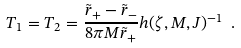Convert formula to latex. <formula><loc_0><loc_0><loc_500><loc_500>T _ { 1 } = T _ { 2 } = \frac { \tilde { r } _ { + } - \tilde { r } _ { - } } { 8 \pi M \tilde { r } _ { + } } h ( \zeta , M , J ) ^ { - 1 } \ .</formula> 